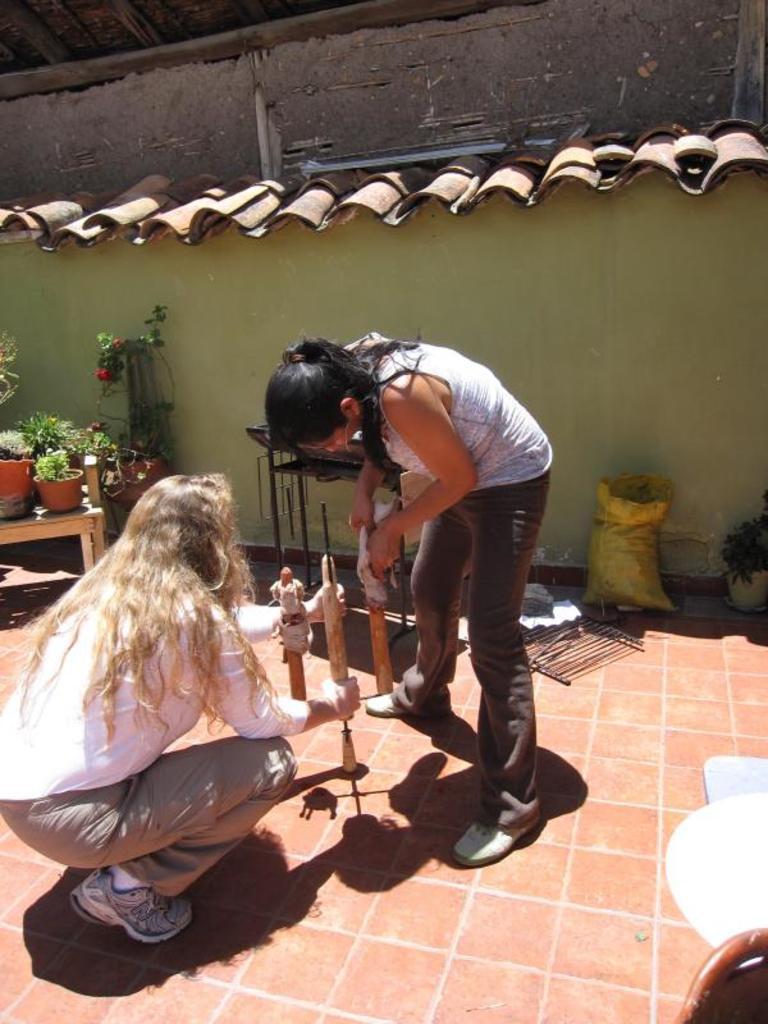Could you give a brief overview of what you see in this image? In this picture, we see the woman is standing and she is holding a wooden stick. The woman on the left side is in squad position and she is also holding the wooden stick. Behind them, we see the iron rods and a plastic bag in yellow color. On the left side, we see a table on which plant pots are placed. In the background, we see a building in green color with a brown color roof. In the right bottom, we see the objects in white and brown color. 